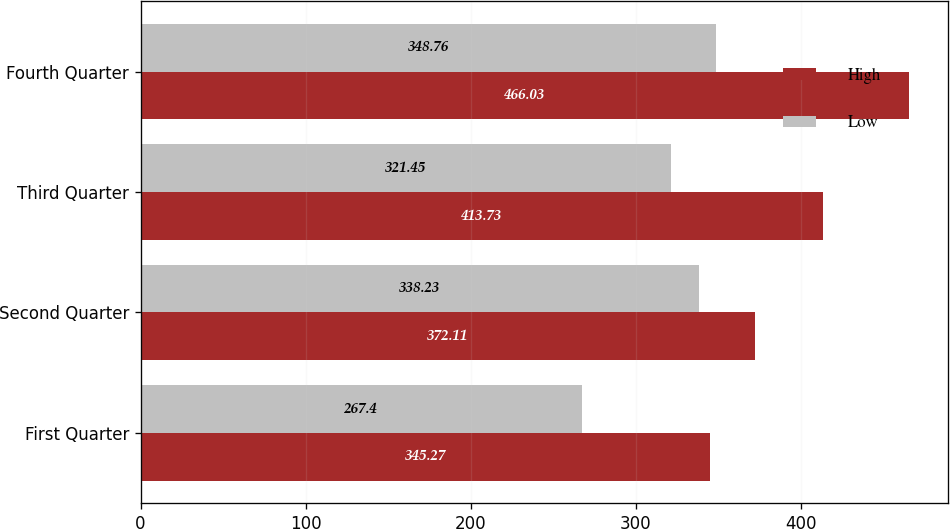<chart> <loc_0><loc_0><loc_500><loc_500><stacked_bar_chart><ecel><fcel>First Quarter<fcel>Second Quarter<fcel>Third Quarter<fcel>Fourth Quarter<nl><fcel>High<fcel>345.27<fcel>372.11<fcel>413.73<fcel>466.03<nl><fcel>Low<fcel>267.4<fcel>338.23<fcel>321.45<fcel>348.76<nl></chart> 